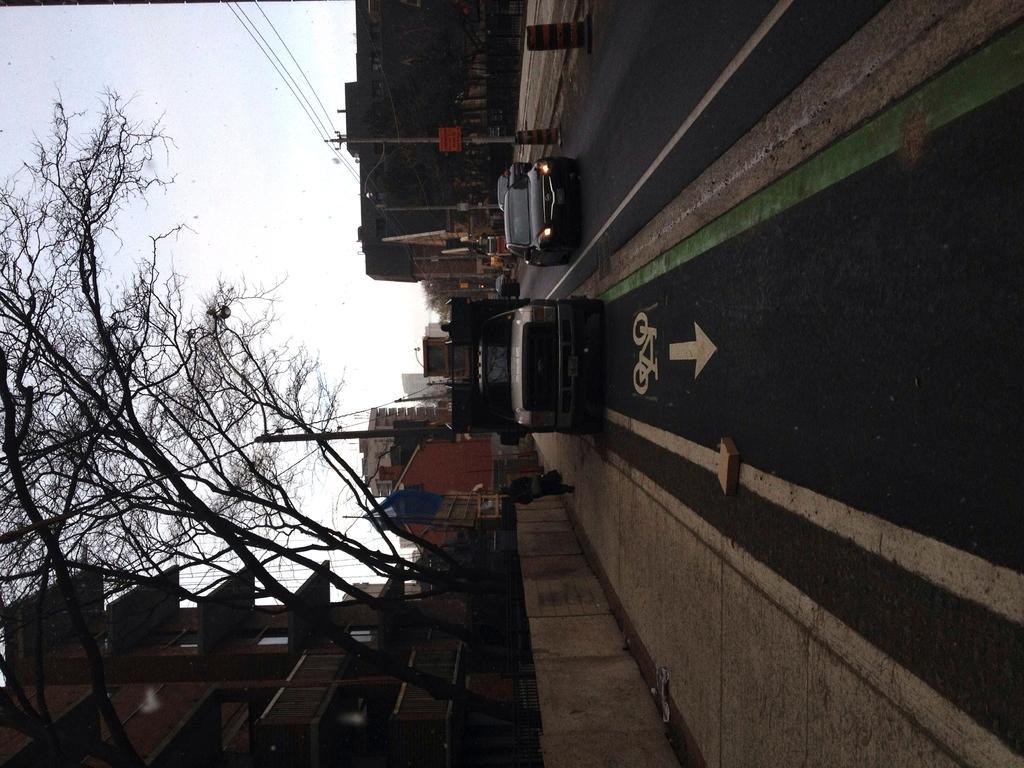In one or two sentences, can you explain what this image depicts? In this image there are buildings, trees, poles, boards, vehicles, a person and objects. Vehicles are on the road. In the background of the image there is the sky.  